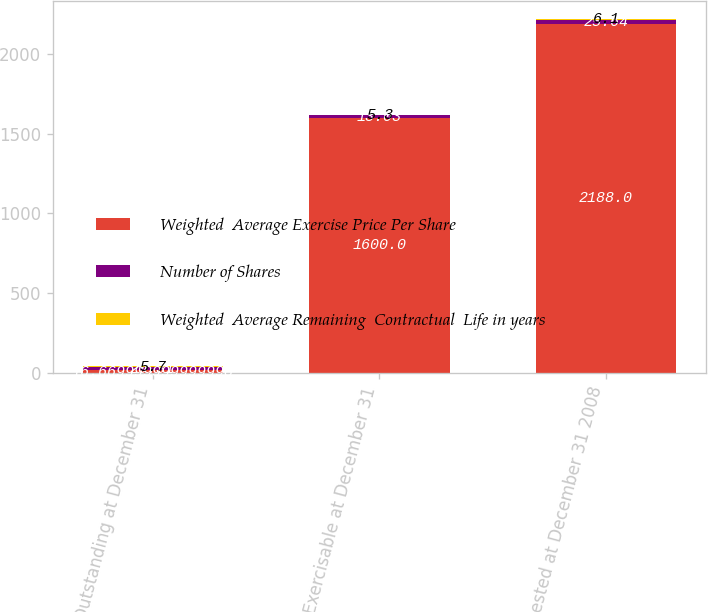Convert chart to OTSL. <chart><loc_0><loc_0><loc_500><loc_500><stacked_bar_chart><ecel><fcel>Outstanding at December 31<fcel>Exercisable at December 31<fcel>Unvested at December 31 2008<nl><fcel>Weighted  Average Exercise Price Per Share<fcel>16.67<fcel>1600<fcel>2188<nl><fcel>Number of Shares<fcel>20.31<fcel>13.03<fcel>25.64<nl><fcel>Weighted  Average Remaining  Contractual  Life in years<fcel>5.7<fcel>5.3<fcel>6.1<nl></chart> 